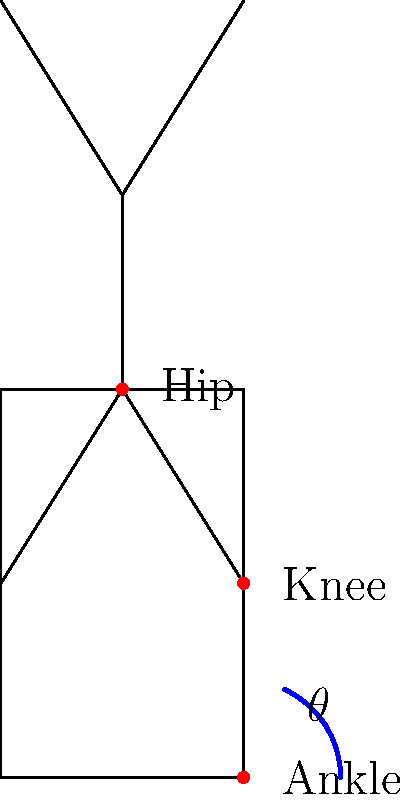In a squat exercise, the knee angle ($\theta$) at the bottom position is typically recommended to be between 90° and 120° for optimal performance and safety. Given that the actual range of motion for the knee joint is approximately 0° to 140°, what percentage of the total knee range of motion does the recommended squat depth utilize, assuming a knee angle of 100° at the bottom of the squat? To solve this problem, we'll follow these steps:

1. Identify the total range of motion for the knee joint:
   Total ROM = 140° - 0° = 140°

2. Determine the range of motion used in the squat:
   Squat ROM = 100° - 0° = 100°
   (We use 0° as the starting point, assuming a fully extended knee at the top of the squat)

3. Calculate the percentage of total ROM used:
   Percentage = (Squat ROM / Total ROM) × 100
   Percentage = (100° / 140°) × 100

4. Perform the calculation:
   Percentage = 0.7142857 × 100 ≈ 71.43%

Therefore, a squat with a knee angle of 100° at the bottom position utilizes approximately 71.43% of the total knee range of motion.
Answer: 71.43% 